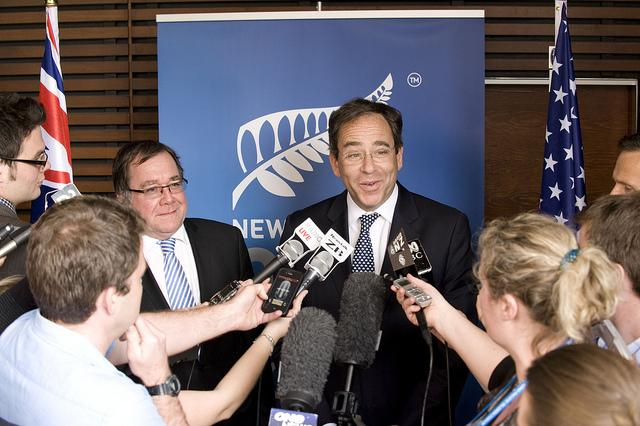Why are the people holding microphones?

Choices:
A) to sing
B) to announce
C) for karaoke
D) to interview to interview 